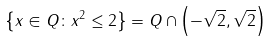<formula> <loc_0><loc_0><loc_500><loc_500>\left \{ x \in Q \colon x ^ { 2 } \leq 2 \right \} = Q \cap \left ( - { \sqrt { 2 } } , { \sqrt { 2 } } \right )</formula> 